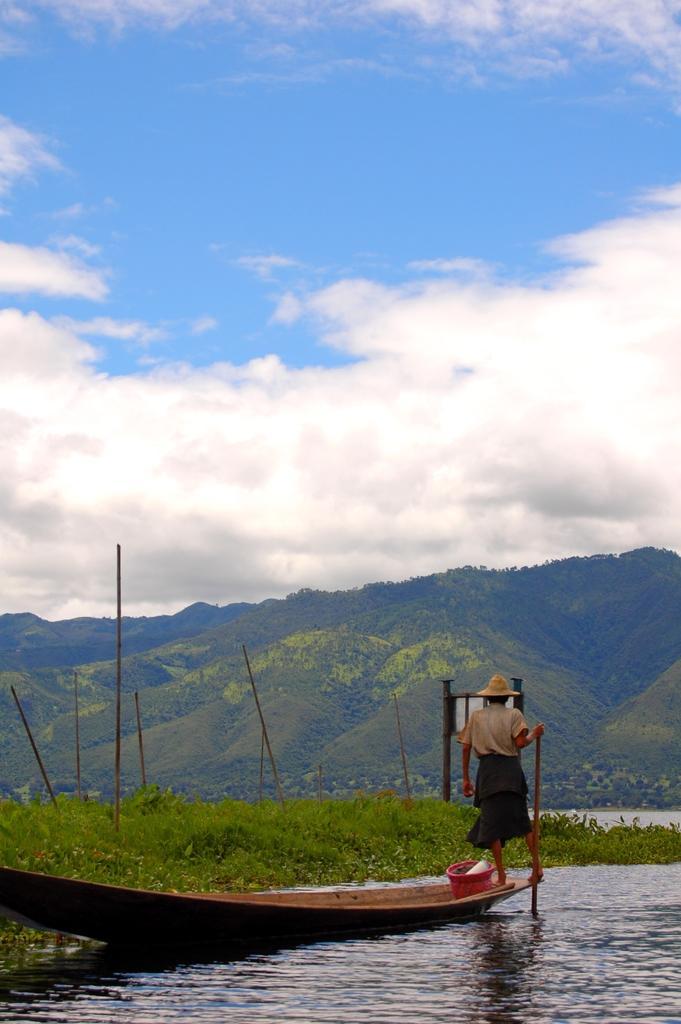Can you describe this image briefly? In this picture we can see a boat on water, here we can see a person, sticks, plants and some objects and in the background we can see mountains and sky with clouds. 